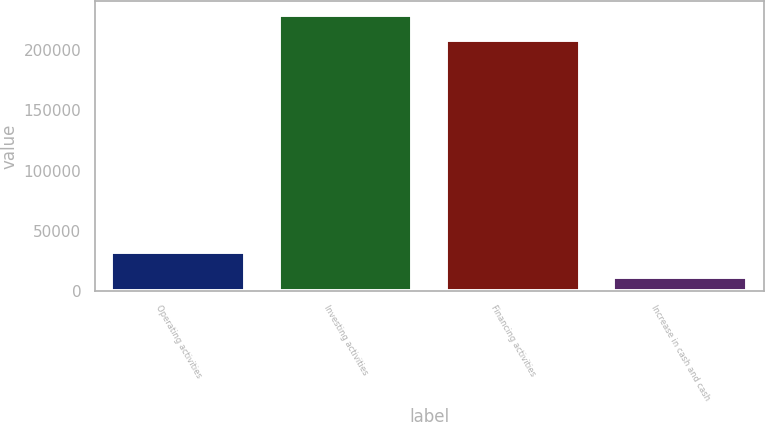<chart> <loc_0><loc_0><loc_500><loc_500><bar_chart><fcel>Operating activities<fcel>Investing activities<fcel>Financing activities<fcel>Increase in cash and cash<nl><fcel>32508.8<fcel>229222<fcel>208495<fcel>11782<nl></chart> 